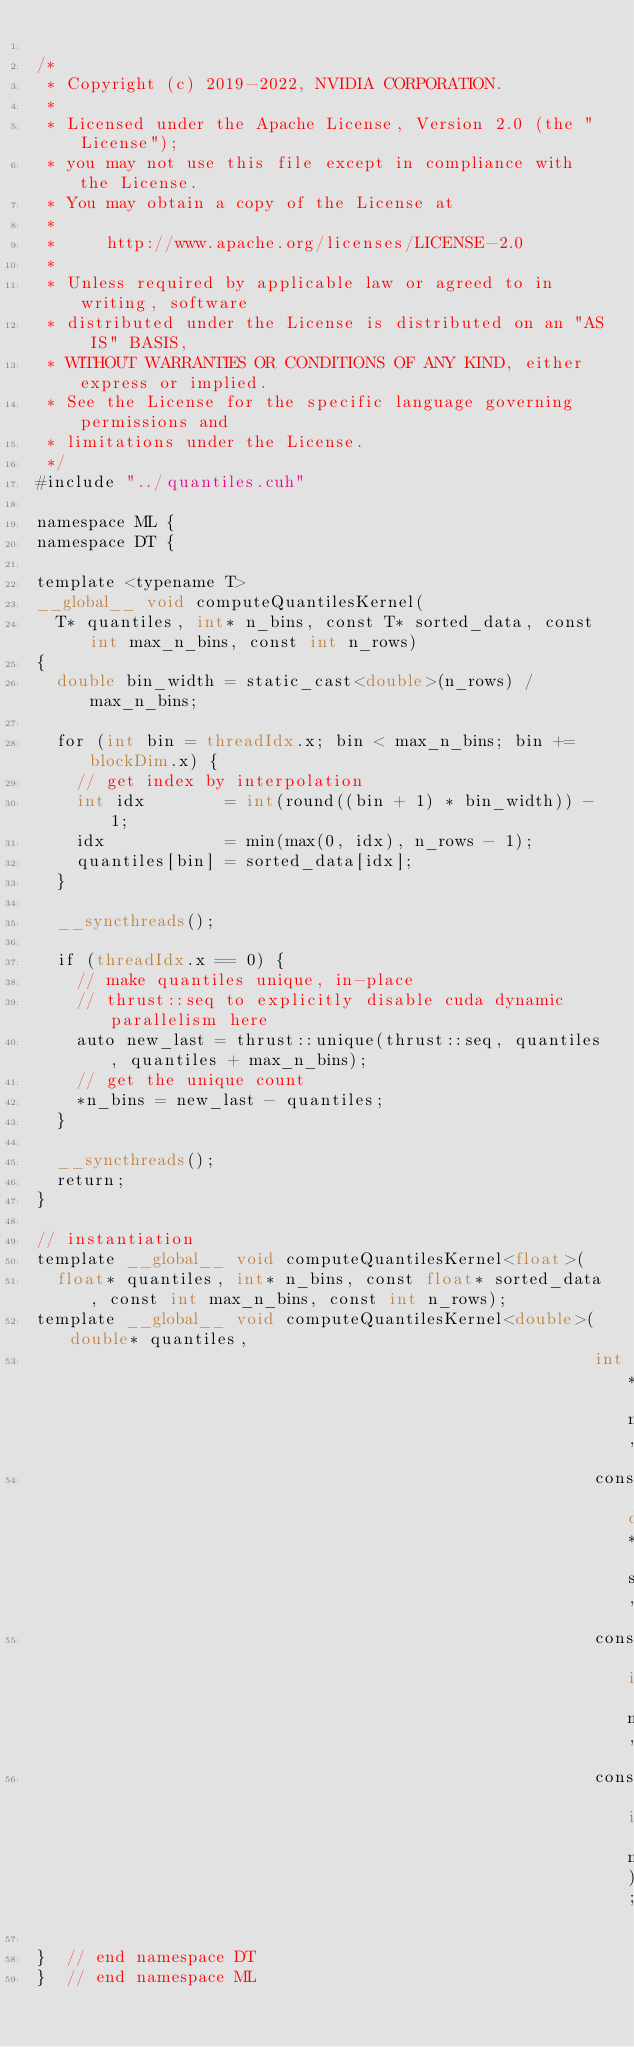Convert code to text. <code><loc_0><loc_0><loc_500><loc_500><_Cuda_>
/*
 * Copyright (c) 2019-2022, NVIDIA CORPORATION.
 *
 * Licensed under the Apache License, Version 2.0 (the "License");
 * you may not use this file except in compliance with the License.
 * You may obtain a copy of the License at
 *
 *     http://www.apache.org/licenses/LICENSE-2.0
 *
 * Unless required by applicable law or agreed to in writing, software
 * distributed under the License is distributed on an "AS IS" BASIS,
 * WITHOUT WARRANTIES OR CONDITIONS OF ANY KIND, either express or implied.
 * See the License for the specific language governing permissions and
 * limitations under the License.
 */
#include "../quantiles.cuh"

namespace ML {
namespace DT {

template <typename T>
__global__ void computeQuantilesKernel(
  T* quantiles, int* n_bins, const T* sorted_data, const int max_n_bins, const int n_rows)
{
  double bin_width = static_cast<double>(n_rows) / max_n_bins;

  for (int bin = threadIdx.x; bin < max_n_bins; bin += blockDim.x) {
    // get index by interpolation
    int idx        = int(round((bin + 1) * bin_width)) - 1;
    idx            = min(max(0, idx), n_rows - 1);
    quantiles[bin] = sorted_data[idx];
  }

  __syncthreads();

  if (threadIdx.x == 0) {
    // make quantiles unique, in-place
    // thrust::seq to explicitly disable cuda dynamic parallelism here
    auto new_last = thrust::unique(thrust::seq, quantiles, quantiles + max_n_bins);
    // get the unique count
    *n_bins = new_last - quantiles;
  }

  __syncthreads();
  return;
}

// instantiation
template __global__ void computeQuantilesKernel<float>(
  float* quantiles, int* n_bins, const float* sorted_data, const int max_n_bins, const int n_rows);
template __global__ void computeQuantilesKernel<double>(double* quantiles,
                                                        int* n_bins,
                                                        const double* sorted_data,
                                                        const int max_n_bins,
                                                        const int n_rows);

}  // end namespace DT
}  // end namespace ML
</code> 